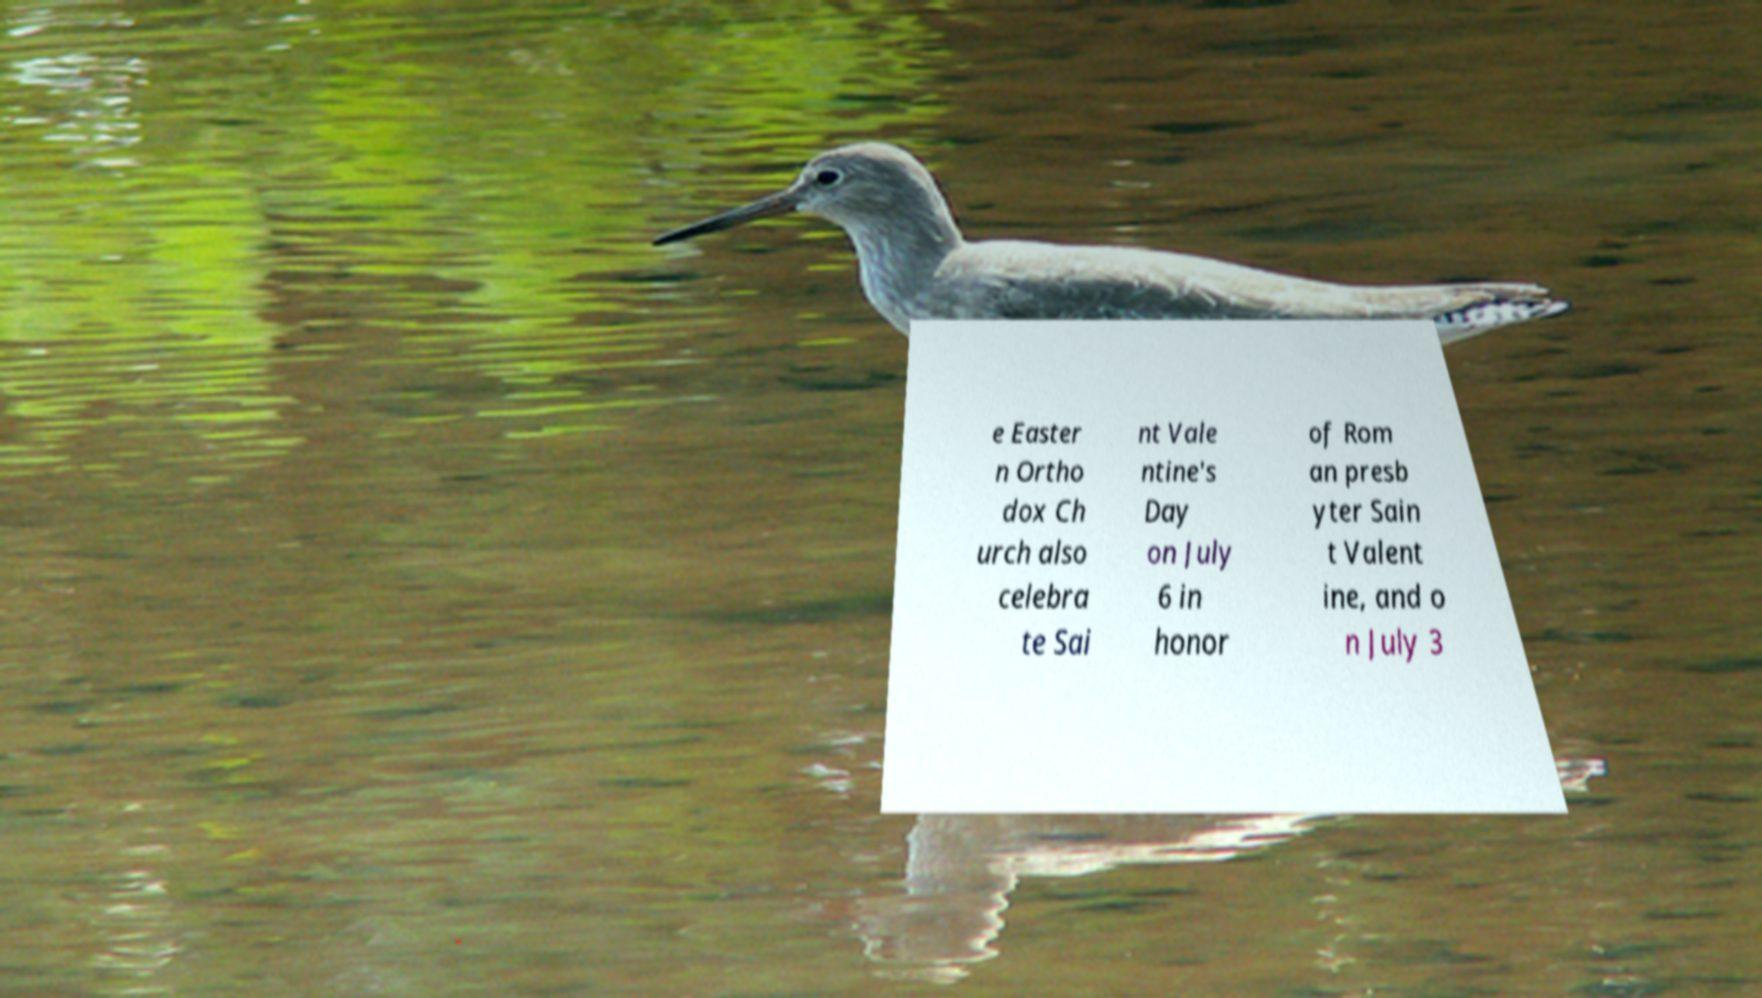There's text embedded in this image that I need extracted. Can you transcribe it verbatim? e Easter n Ortho dox Ch urch also celebra te Sai nt Vale ntine's Day on July 6 in honor of Rom an presb yter Sain t Valent ine, and o n July 3 